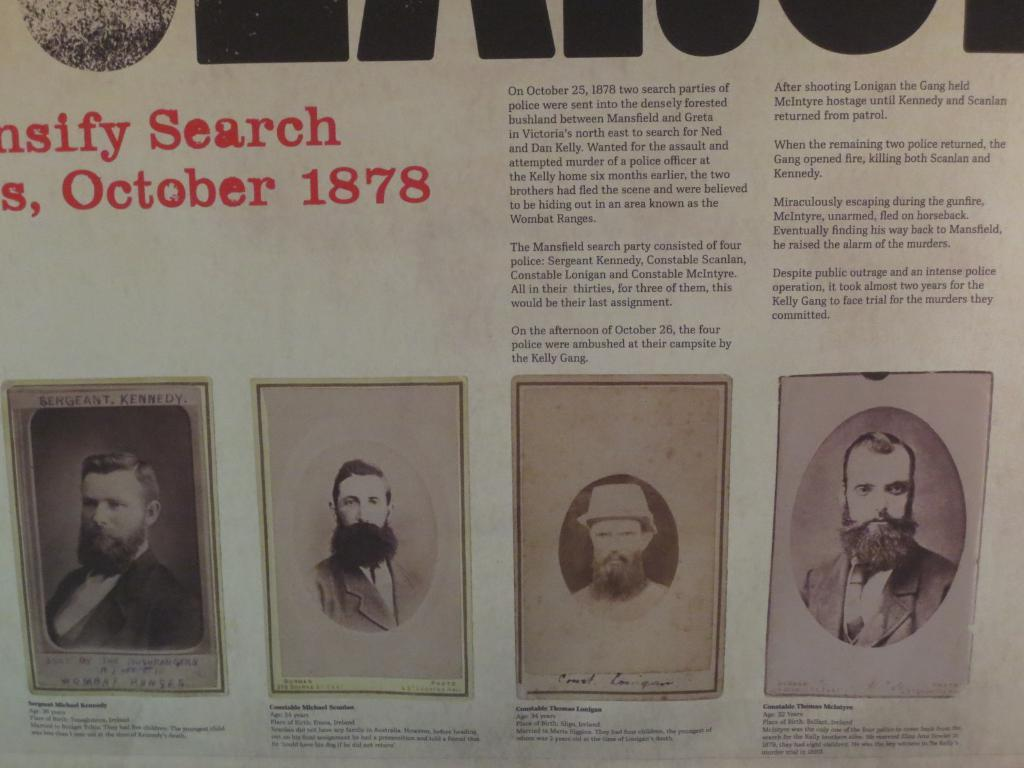What type of publication is visible in the image? There is a magazine in the image. What kind of content can be found in the magazine? The magazine contains information and images. Where is the secretary located in the image? There is no secretary present in the image. What type of pipe can be seen running through the airport in the image? There is no airport or pipe present in the image. 